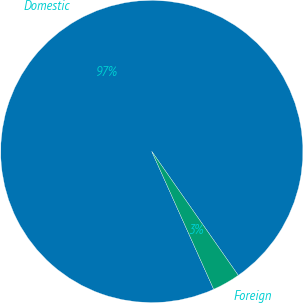<chart> <loc_0><loc_0><loc_500><loc_500><pie_chart><fcel>Domestic<fcel>Foreign<nl><fcel>97.02%<fcel>2.98%<nl></chart> 